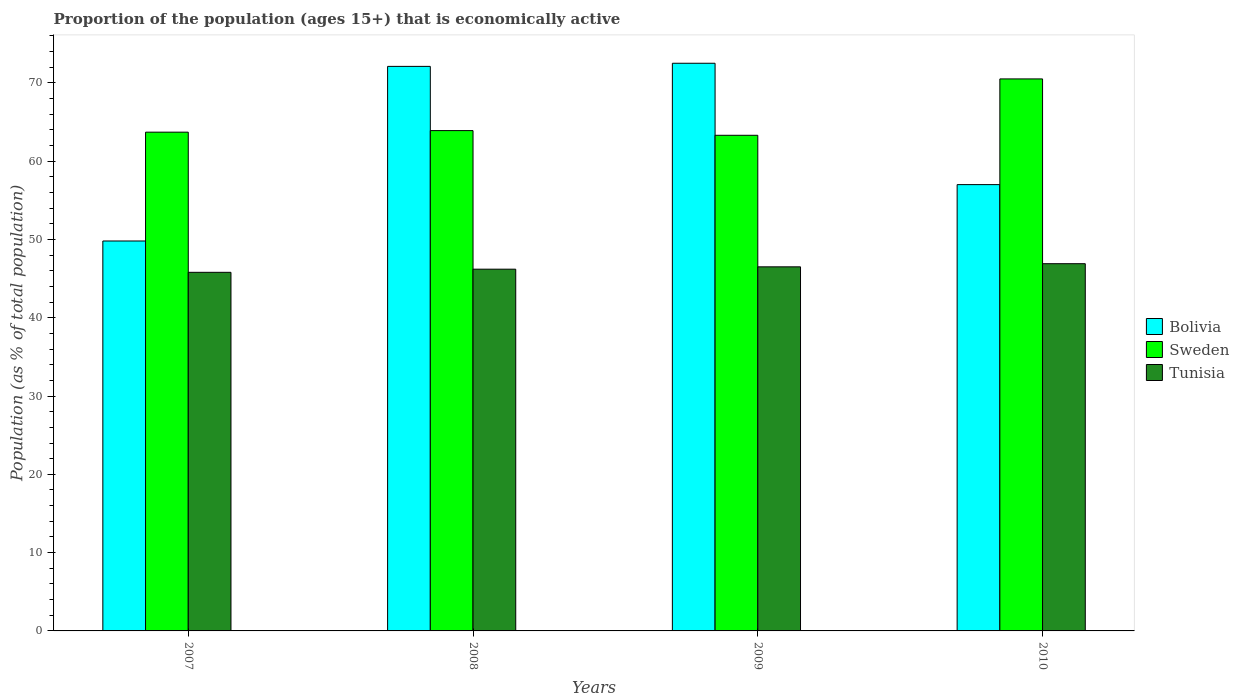How many different coloured bars are there?
Make the answer very short. 3. How many groups of bars are there?
Ensure brevity in your answer.  4. Are the number of bars per tick equal to the number of legend labels?
Offer a terse response. Yes. How many bars are there on the 2nd tick from the left?
Make the answer very short. 3. What is the label of the 1st group of bars from the left?
Provide a succinct answer. 2007. What is the proportion of the population that is economically active in Bolivia in 2009?
Offer a very short reply. 72.5. Across all years, what is the maximum proportion of the population that is economically active in Sweden?
Offer a terse response. 70.5. Across all years, what is the minimum proportion of the population that is economically active in Tunisia?
Your response must be concise. 45.8. In which year was the proportion of the population that is economically active in Sweden minimum?
Your response must be concise. 2009. What is the total proportion of the population that is economically active in Tunisia in the graph?
Your answer should be very brief. 185.4. What is the difference between the proportion of the population that is economically active in Bolivia in 2008 and that in 2009?
Your response must be concise. -0.4. What is the difference between the proportion of the population that is economically active in Tunisia in 2008 and the proportion of the population that is economically active in Bolivia in 2009?
Make the answer very short. -26.3. What is the average proportion of the population that is economically active in Bolivia per year?
Make the answer very short. 62.85. In the year 2007, what is the difference between the proportion of the population that is economically active in Bolivia and proportion of the population that is economically active in Sweden?
Provide a short and direct response. -13.9. In how many years, is the proportion of the population that is economically active in Tunisia greater than 50 %?
Provide a succinct answer. 0. What is the ratio of the proportion of the population that is economically active in Sweden in 2007 to that in 2010?
Your answer should be very brief. 0.9. What is the difference between the highest and the second highest proportion of the population that is economically active in Tunisia?
Give a very brief answer. 0.4. What is the difference between the highest and the lowest proportion of the population that is economically active in Sweden?
Make the answer very short. 7.2. What does the 2nd bar from the left in 2009 represents?
Your response must be concise. Sweden. What does the 1st bar from the right in 2009 represents?
Offer a very short reply. Tunisia. Is it the case that in every year, the sum of the proportion of the population that is economically active in Sweden and proportion of the population that is economically active in Tunisia is greater than the proportion of the population that is economically active in Bolivia?
Provide a succinct answer. Yes. Are all the bars in the graph horizontal?
Your response must be concise. No. How many years are there in the graph?
Your answer should be very brief. 4. What is the title of the graph?
Offer a very short reply. Proportion of the population (ages 15+) that is economically active. Does "Papua New Guinea" appear as one of the legend labels in the graph?
Your answer should be compact. No. What is the label or title of the Y-axis?
Give a very brief answer. Population (as % of total population). What is the Population (as % of total population) of Bolivia in 2007?
Give a very brief answer. 49.8. What is the Population (as % of total population) of Sweden in 2007?
Your response must be concise. 63.7. What is the Population (as % of total population) in Tunisia in 2007?
Your answer should be compact. 45.8. What is the Population (as % of total population) in Bolivia in 2008?
Your answer should be very brief. 72.1. What is the Population (as % of total population) in Sweden in 2008?
Your answer should be compact. 63.9. What is the Population (as % of total population) in Tunisia in 2008?
Offer a terse response. 46.2. What is the Population (as % of total population) in Bolivia in 2009?
Offer a terse response. 72.5. What is the Population (as % of total population) in Sweden in 2009?
Your answer should be very brief. 63.3. What is the Population (as % of total population) in Tunisia in 2009?
Your response must be concise. 46.5. What is the Population (as % of total population) in Sweden in 2010?
Provide a short and direct response. 70.5. What is the Population (as % of total population) in Tunisia in 2010?
Provide a succinct answer. 46.9. Across all years, what is the maximum Population (as % of total population) of Bolivia?
Your answer should be compact. 72.5. Across all years, what is the maximum Population (as % of total population) in Sweden?
Provide a short and direct response. 70.5. Across all years, what is the maximum Population (as % of total population) of Tunisia?
Your answer should be compact. 46.9. Across all years, what is the minimum Population (as % of total population) of Bolivia?
Offer a terse response. 49.8. Across all years, what is the minimum Population (as % of total population) of Sweden?
Your answer should be very brief. 63.3. Across all years, what is the minimum Population (as % of total population) in Tunisia?
Provide a short and direct response. 45.8. What is the total Population (as % of total population) of Bolivia in the graph?
Your response must be concise. 251.4. What is the total Population (as % of total population) of Sweden in the graph?
Make the answer very short. 261.4. What is the total Population (as % of total population) in Tunisia in the graph?
Provide a short and direct response. 185.4. What is the difference between the Population (as % of total population) in Bolivia in 2007 and that in 2008?
Provide a short and direct response. -22.3. What is the difference between the Population (as % of total population) in Sweden in 2007 and that in 2008?
Your answer should be very brief. -0.2. What is the difference between the Population (as % of total population) of Tunisia in 2007 and that in 2008?
Provide a succinct answer. -0.4. What is the difference between the Population (as % of total population) of Bolivia in 2007 and that in 2009?
Ensure brevity in your answer.  -22.7. What is the difference between the Population (as % of total population) in Sweden in 2007 and that in 2009?
Offer a very short reply. 0.4. What is the difference between the Population (as % of total population) in Tunisia in 2007 and that in 2009?
Provide a succinct answer. -0.7. What is the difference between the Population (as % of total population) of Sweden in 2007 and that in 2010?
Your response must be concise. -6.8. What is the difference between the Population (as % of total population) of Bolivia in 2008 and that in 2009?
Provide a short and direct response. -0.4. What is the difference between the Population (as % of total population) of Tunisia in 2008 and that in 2010?
Offer a very short reply. -0.7. What is the difference between the Population (as % of total population) of Bolivia in 2009 and that in 2010?
Ensure brevity in your answer.  15.5. What is the difference between the Population (as % of total population) of Sweden in 2009 and that in 2010?
Provide a short and direct response. -7.2. What is the difference between the Population (as % of total population) in Tunisia in 2009 and that in 2010?
Your response must be concise. -0.4. What is the difference between the Population (as % of total population) in Bolivia in 2007 and the Population (as % of total population) in Sweden in 2008?
Provide a succinct answer. -14.1. What is the difference between the Population (as % of total population) of Bolivia in 2007 and the Population (as % of total population) of Sweden in 2009?
Offer a terse response. -13.5. What is the difference between the Population (as % of total population) of Bolivia in 2007 and the Population (as % of total population) of Sweden in 2010?
Offer a very short reply. -20.7. What is the difference between the Population (as % of total population) of Bolivia in 2007 and the Population (as % of total population) of Tunisia in 2010?
Your answer should be very brief. 2.9. What is the difference between the Population (as % of total population) of Bolivia in 2008 and the Population (as % of total population) of Sweden in 2009?
Keep it short and to the point. 8.8. What is the difference between the Population (as % of total population) in Bolivia in 2008 and the Population (as % of total population) in Tunisia in 2009?
Offer a terse response. 25.6. What is the difference between the Population (as % of total population) of Sweden in 2008 and the Population (as % of total population) of Tunisia in 2009?
Provide a succinct answer. 17.4. What is the difference between the Population (as % of total population) of Bolivia in 2008 and the Population (as % of total population) of Tunisia in 2010?
Make the answer very short. 25.2. What is the difference between the Population (as % of total population) in Bolivia in 2009 and the Population (as % of total population) in Tunisia in 2010?
Provide a succinct answer. 25.6. What is the average Population (as % of total population) of Bolivia per year?
Your response must be concise. 62.85. What is the average Population (as % of total population) in Sweden per year?
Give a very brief answer. 65.35. What is the average Population (as % of total population) of Tunisia per year?
Provide a short and direct response. 46.35. In the year 2007, what is the difference between the Population (as % of total population) of Bolivia and Population (as % of total population) of Sweden?
Your response must be concise. -13.9. In the year 2008, what is the difference between the Population (as % of total population) of Bolivia and Population (as % of total population) of Sweden?
Your answer should be compact. 8.2. In the year 2008, what is the difference between the Population (as % of total population) in Bolivia and Population (as % of total population) in Tunisia?
Your response must be concise. 25.9. In the year 2008, what is the difference between the Population (as % of total population) in Sweden and Population (as % of total population) in Tunisia?
Offer a very short reply. 17.7. In the year 2009, what is the difference between the Population (as % of total population) of Bolivia and Population (as % of total population) of Sweden?
Offer a very short reply. 9.2. In the year 2009, what is the difference between the Population (as % of total population) of Bolivia and Population (as % of total population) of Tunisia?
Make the answer very short. 26. In the year 2009, what is the difference between the Population (as % of total population) in Sweden and Population (as % of total population) in Tunisia?
Ensure brevity in your answer.  16.8. In the year 2010, what is the difference between the Population (as % of total population) of Bolivia and Population (as % of total population) of Tunisia?
Keep it short and to the point. 10.1. In the year 2010, what is the difference between the Population (as % of total population) of Sweden and Population (as % of total population) of Tunisia?
Give a very brief answer. 23.6. What is the ratio of the Population (as % of total population) in Bolivia in 2007 to that in 2008?
Provide a short and direct response. 0.69. What is the ratio of the Population (as % of total population) of Sweden in 2007 to that in 2008?
Your response must be concise. 1. What is the ratio of the Population (as % of total population) of Tunisia in 2007 to that in 2008?
Ensure brevity in your answer.  0.99. What is the ratio of the Population (as % of total population) in Bolivia in 2007 to that in 2009?
Offer a terse response. 0.69. What is the ratio of the Population (as % of total population) in Tunisia in 2007 to that in 2009?
Keep it short and to the point. 0.98. What is the ratio of the Population (as % of total population) in Bolivia in 2007 to that in 2010?
Make the answer very short. 0.87. What is the ratio of the Population (as % of total population) in Sweden in 2007 to that in 2010?
Provide a succinct answer. 0.9. What is the ratio of the Population (as % of total population) in Tunisia in 2007 to that in 2010?
Offer a very short reply. 0.98. What is the ratio of the Population (as % of total population) in Bolivia in 2008 to that in 2009?
Offer a terse response. 0.99. What is the ratio of the Population (as % of total population) in Sweden in 2008 to that in 2009?
Offer a very short reply. 1.01. What is the ratio of the Population (as % of total population) in Tunisia in 2008 to that in 2009?
Ensure brevity in your answer.  0.99. What is the ratio of the Population (as % of total population) in Bolivia in 2008 to that in 2010?
Provide a succinct answer. 1.26. What is the ratio of the Population (as % of total population) of Sweden in 2008 to that in 2010?
Ensure brevity in your answer.  0.91. What is the ratio of the Population (as % of total population) in Tunisia in 2008 to that in 2010?
Provide a succinct answer. 0.99. What is the ratio of the Population (as % of total population) in Bolivia in 2009 to that in 2010?
Your response must be concise. 1.27. What is the ratio of the Population (as % of total population) of Sweden in 2009 to that in 2010?
Ensure brevity in your answer.  0.9. What is the difference between the highest and the second highest Population (as % of total population) of Bolivia?
Offer a very short reply. 0.4. What is the difference between the highest and the lowest Population (as % of total population) in Bolivia?
Your answer should be very brief. 22.7. What is the difference between the highest and the lowest Population (as % of total population) in Sweden?
Ensure brevity in your answer.  7.2. What is the difference between the highest and the lowest Population (as % of total population) of Tunisia?
Your answer should be very brief. 1.1. 